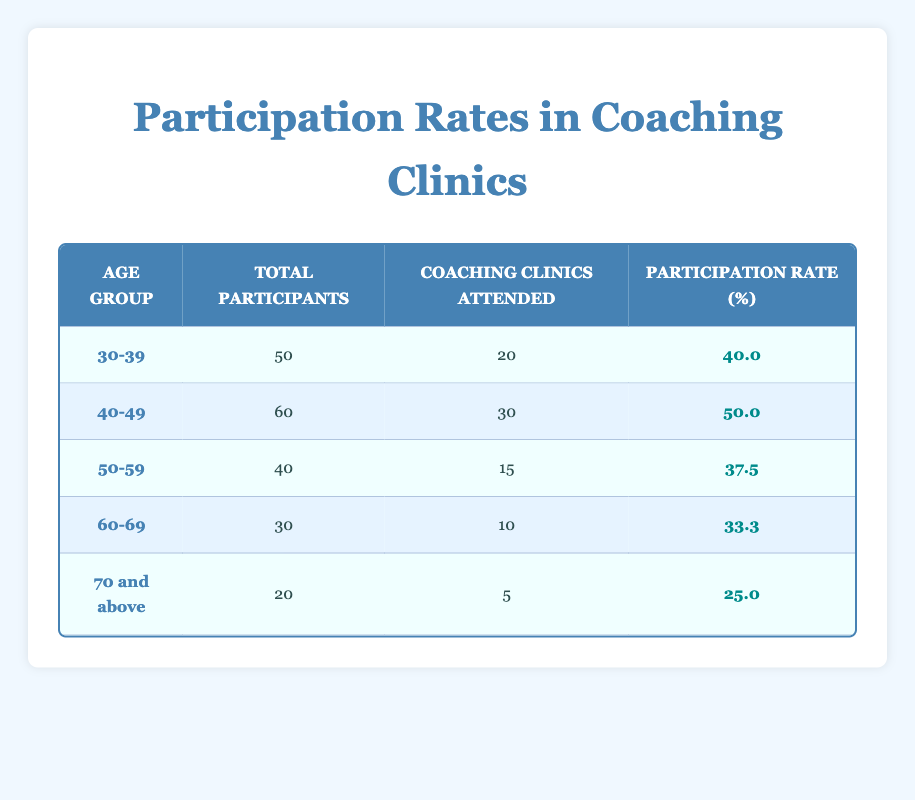What is the participation rate for the age group 40-49? The table shows that the participation rate for the age group 40-49 is listed directly in the corresponding row, which states the participation rate is 50.0% for this group.
Answer: 50.0% How many coaching clinics did participants aged 60-69 attend? Referring to the row for the age group 60-69 in the table, it indicates that the number of coaching clinics attended by this group is 10.
Answer: 10 Which age group has the highest participation rate? By comparing the participation rates across all age groups in the table, the 40-49 age group has the highest participation rate at 50.0%.
Answer: 40-49 What is the total number of participants across all age groups? To find the total number of participants, we need to sum the Total Participants for each age group: 50 + 60 + 40 + 30 + 20 = 200.
Answer: 200 Is the participation rate for the 70 and above age group higher than the 60-69 age group? Comparing the participation rates, 70 and above has a rate of 25.0% while 60-69 has a higher rate of 33.3%. Therefore, the statement is false.
Answer: No What is the average participation rate for the age groups 50-59 and 60-69? To find the average, first add the participation rates for these groups (37.5 + 33.3 = 70.8). Then divide by the number of groups (2): 70.8 / 2 = 35.4.
Answer: 35.4 How many total participants attended coaching clinics in the age group 30-39 compared to the age group 50-59? The age group 30-39 has 20 coaching clinics attended while the age group 50-59 has only 15. Therefore, 30-39 attended more clinics than 50-59.
Answer: 20 vs 15 What percentage of participants in the age group 70 and above attended coaching clinics? The participation rate for the age group 70 and above is given directly in the table as 25.0%. This means 25% of the participants in this group attended clinics.
Answer: 25.0% 